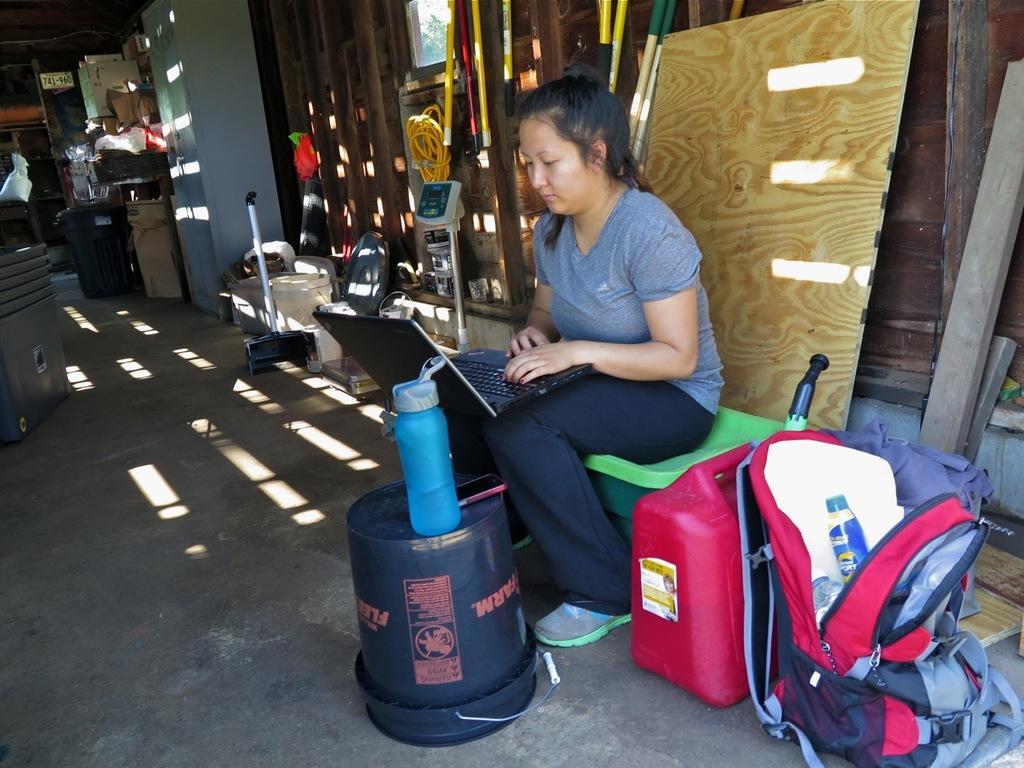Please provide a concise description of this image. in the picture there is a woman sitting and doing some work with a laptop on her laps here we can also see a bag beside her we can different items on the room. 